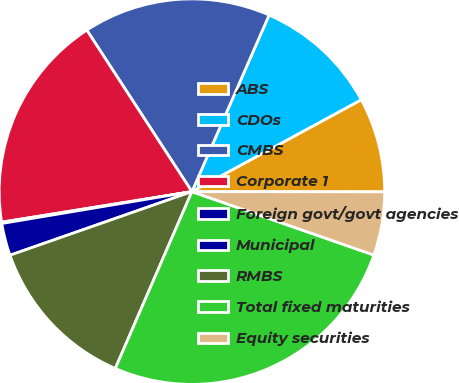Convert chart to OTSL. <chart><loc_0><loc_0><loc_500><loc_500><pie_chart><fcel>ABS<fcel>CDOs<fcel>CMBS<fcel>Corporate 1<fcel>Foreign govt/govt agencies<fcel>Municipal<fcel>RMBS<fcel>Total fixed maturities<fcel>Equity securities<nl><fcel>7.93%<fcel>10.53%<fcel>15.74%<fcel>18.35%<fcel>0.11%<fcel>2.71%<fcel>13.14%<fcel>26.17%<fcel>5.32%<nl></chart> 